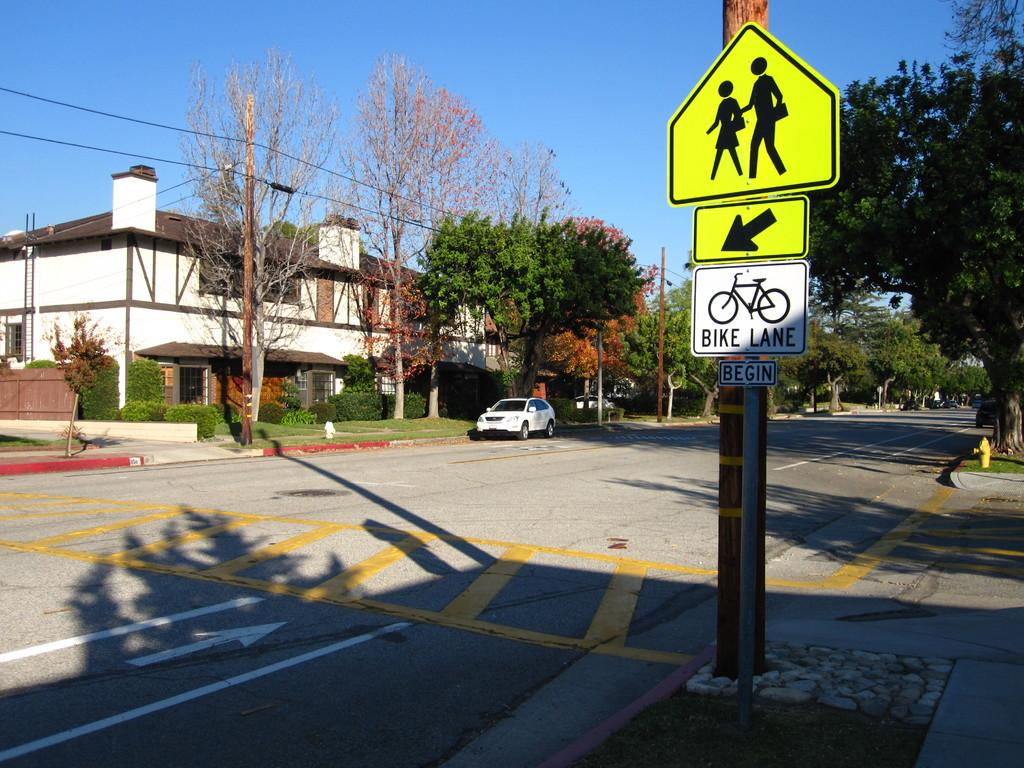<image>
Give a short and clear explanation of the subsequent image. A street sign marking the beginning of a bike lane 